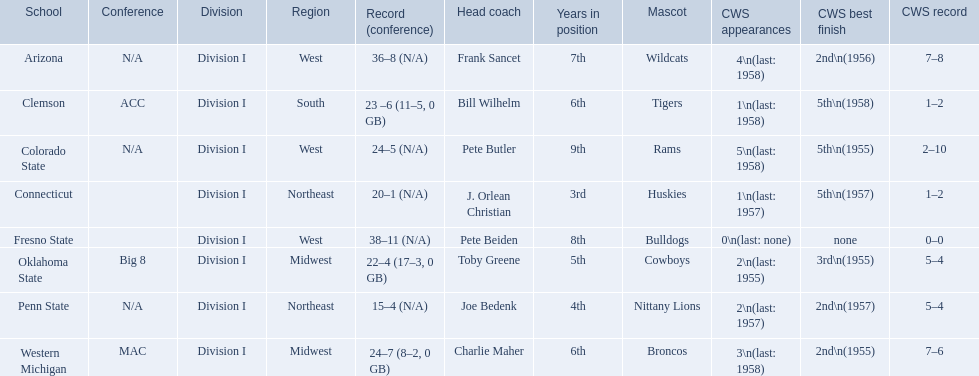How many cws appearances does clemson have? 1\n(last: 1958). How many cws appearances does western michigan have? 3\n(last: 1958). Which of these schools has more cws appearances? Western Michigan. 